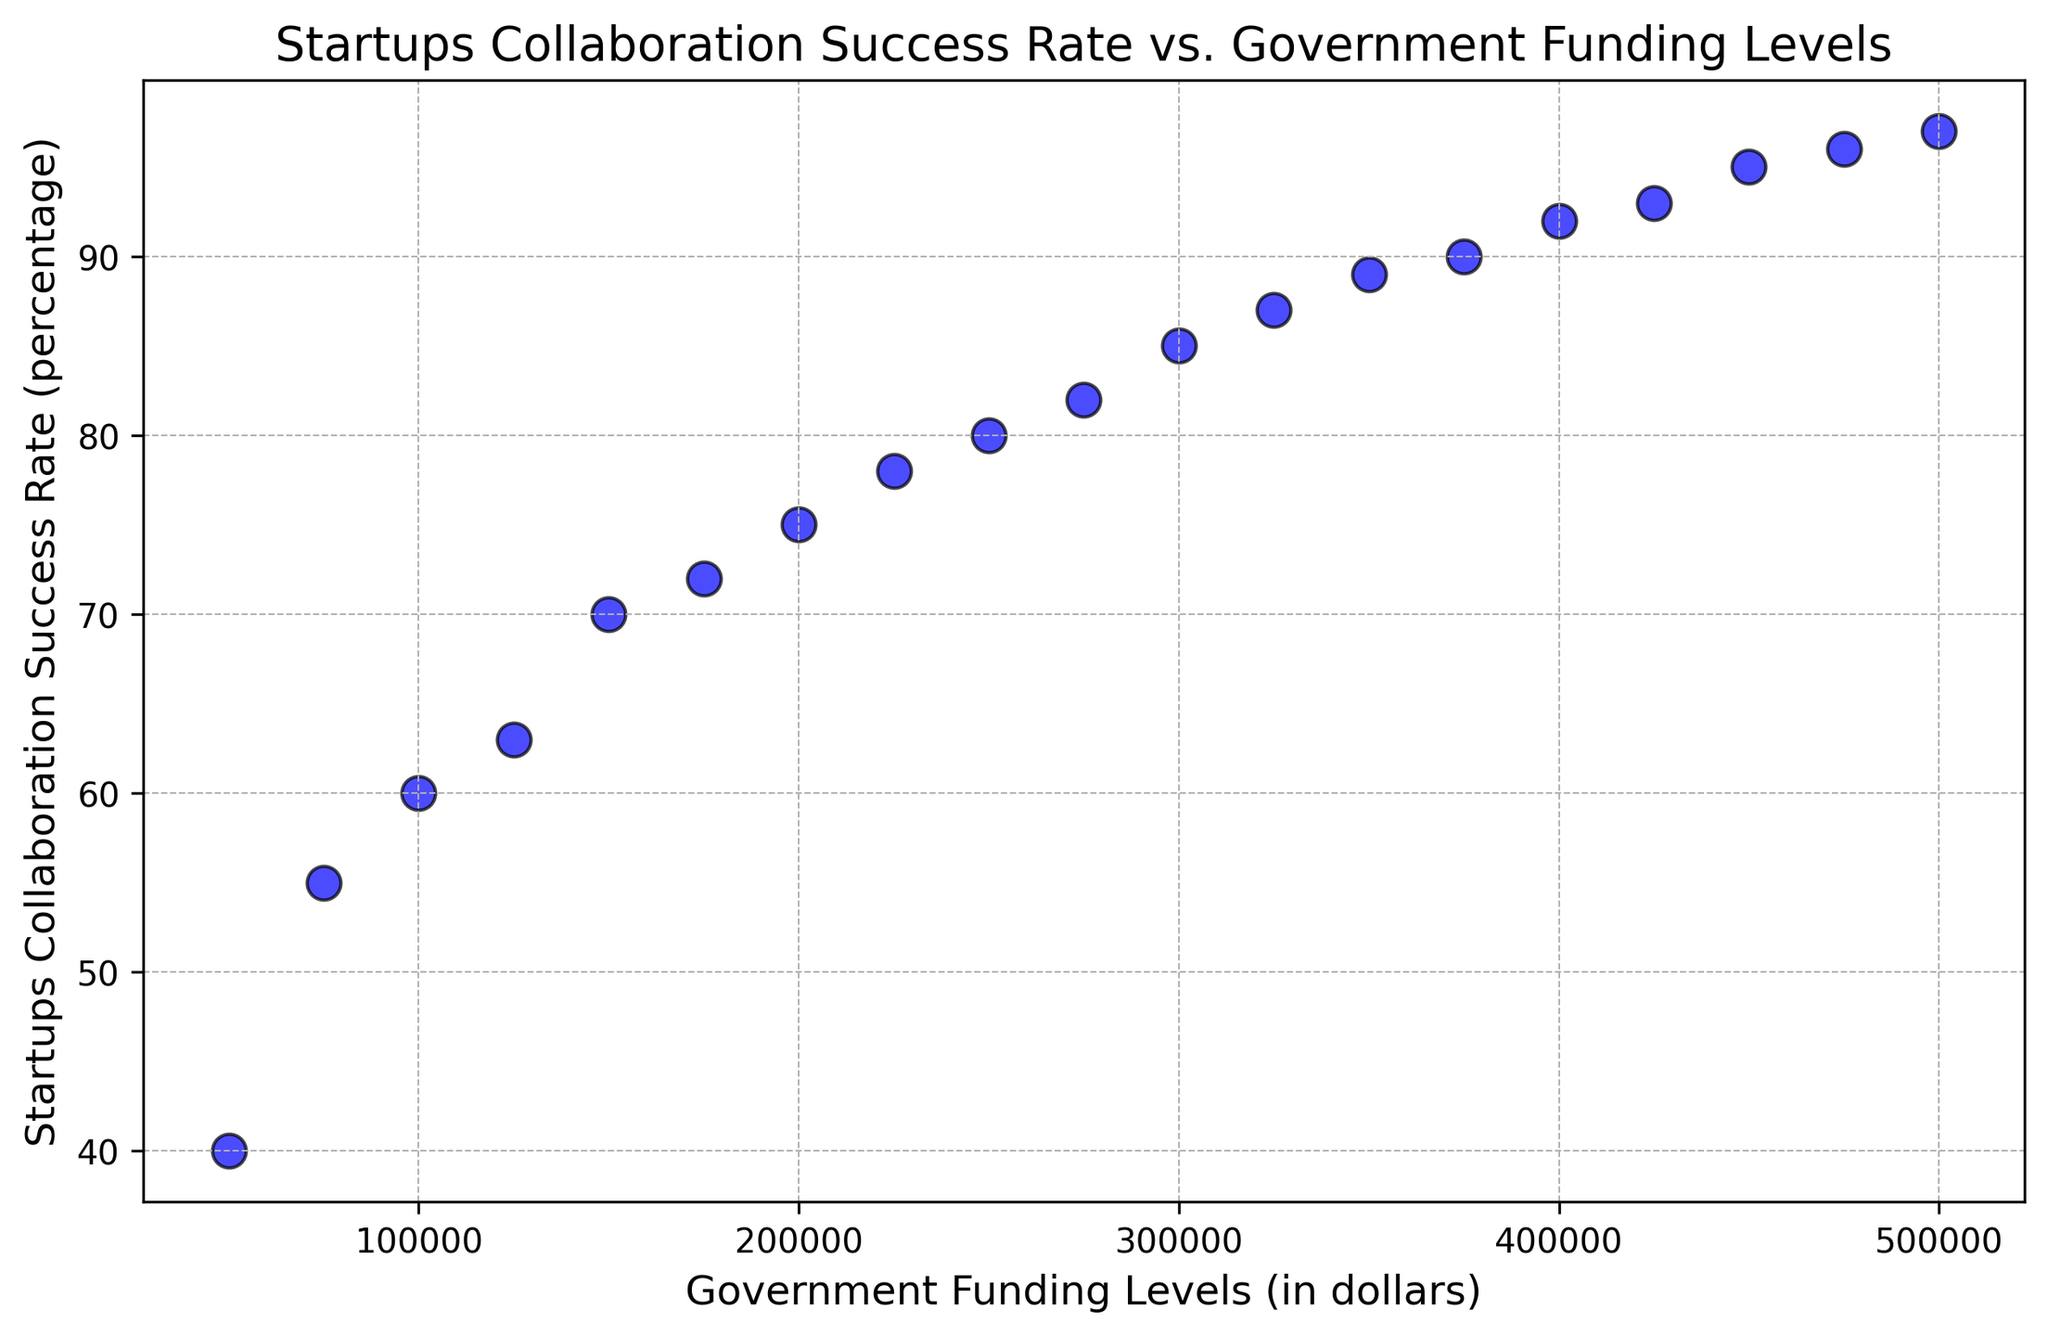How does the startups collaboration success rate change as government funding levels increase? As the government funding levels increase, the startups collaboration success rate generally increases. This can be observed from the upward trend in the scatter plot, where higher funding levels correspond to higher success rates.
Answer: Increases What is the collaboration success rate when the government funding level is $200,000? To find the collaboration success rate at $200,000, locate this value on the x-axis and follow the corresponding point vertically to its y-value. The point at $200,000 on the x-axis corresponds to approximately 75% on the y-axis.
Answer: 75% By how much does the collaboration success rate increase when the government funding level increases from $150,000 to $450,000? Locate the points for $150,000 and $450,000 on the x-axis, and observe the corresponding y-values. For $150,000, the success rate is 70%, and for $450,000, it is 95%. The increase is 95% - 70% = 25%.
Answer: 25% Which point on the scatter plot represents the highest startups collaboration success rate and what is the corresponding government funding level? Locate the highest point vertically on the scatter plot, which represents the highest success rate of 97%. The corresponding government funding level is $500,000, as seen on the x-axis.
Answer: $500,000 Which funding level corresponds to a 90% startup collaboration success rate? Locate the point at 90% on the y-axis and trace it horizontally to find the x-value. The corresponding government funding level is $375,000.
Answer: $375,000 What is the average startups collaboration success rate for funding levels $200,000 and $400,000? Identify the success rates for $200,000 and $400,000, which are 75% and 92%, respectively. Calculate the average: (75% + 92%) / 2 = 83.5%.
Answer: 83.5% Does the scatter plot exhibit any outliers, and if so, where? Examine the spread of the points on the scatter plot. All points appear to follow a consistent upward trend, indicating no significant outliers.
Answer: No outliers How does the success rate at a funding level of $100,000 compare to that at $300,000? Locate the points for $100,000 and $300,000 on the x-axis and compare their y-values. The success rate at $100,000 is 60%, while at $300,000, it is 85%. The success rate at $300,000 is significantly higher than at $100,000.
Answer: Higher at $300,000 What funding level is required to achieve at least an 85% success rate? Identify the points on the scatter plot where the success rate is 85% or higher. The smallest funding level that meets this criterion is $300,000.
Answer: $300,000 By what percentage does the collaboration success rate increase when the funding level rises from $50,000 to $100,000? Determine the success rates for $50,000 and $100,000, which are 40% and 60%, respectively. Calculate the percentage increase: ((60% - 40%) / 40%) * 100% = 50%.
Answer: 50% 